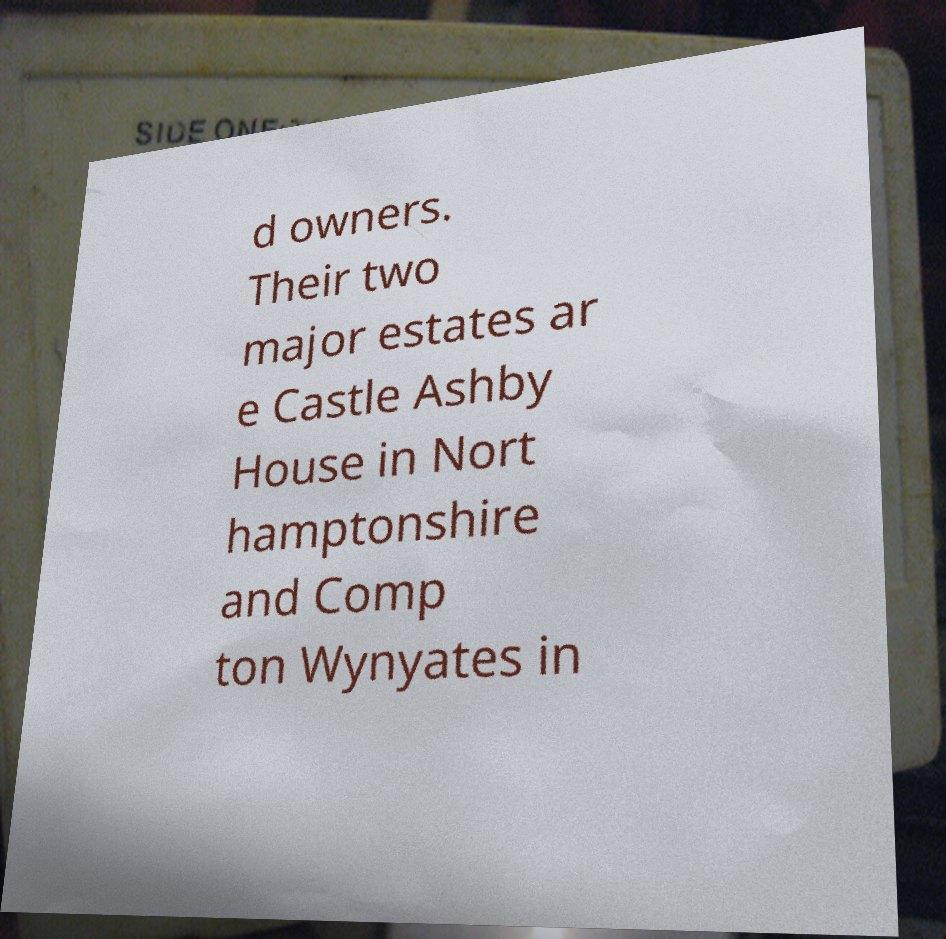Could you assist in decoding the text presented in this image and type it out clearly? d owners. Their two major estates ar e Castle Ashby House in Nort hamptonshire and Comp ton Wynyates in 